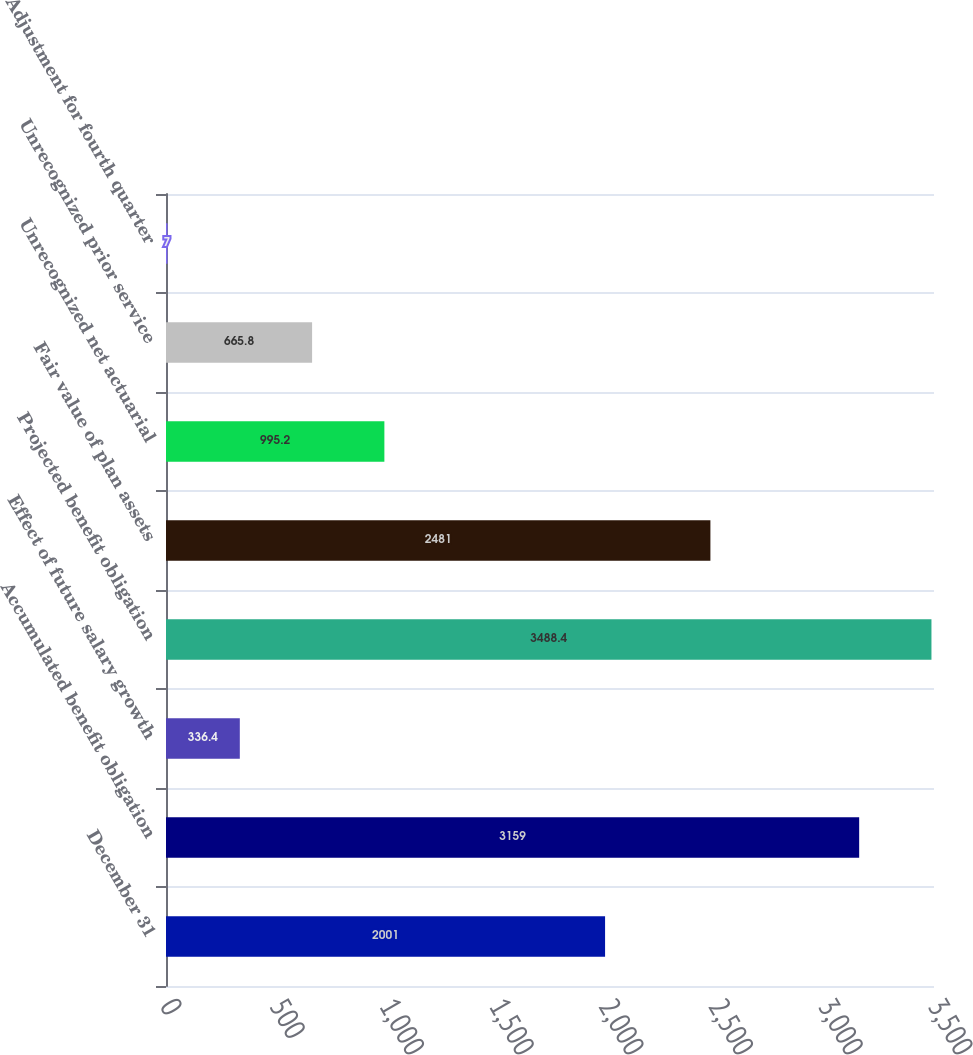<chart> <loc_0><loc_0><loc_500><loc_500><bar_chart><fcel>December 31<fcel>Accumulated benefit obligation<fcel>Effect of future salary growth<fcel>Projected benefit obligation<fcel>Fair value of plan assets<fcel>Unrecognized net actuarial<fcel>Unrecognized prior service<fcel>Adjustment for fourth quarter<nl><fcel>2001<fcel>3159<fcel>336.4<fcel>3488.4<fcel>2481<fcel>995.2<fcel>665.8<fcel>7<nl></chart> 